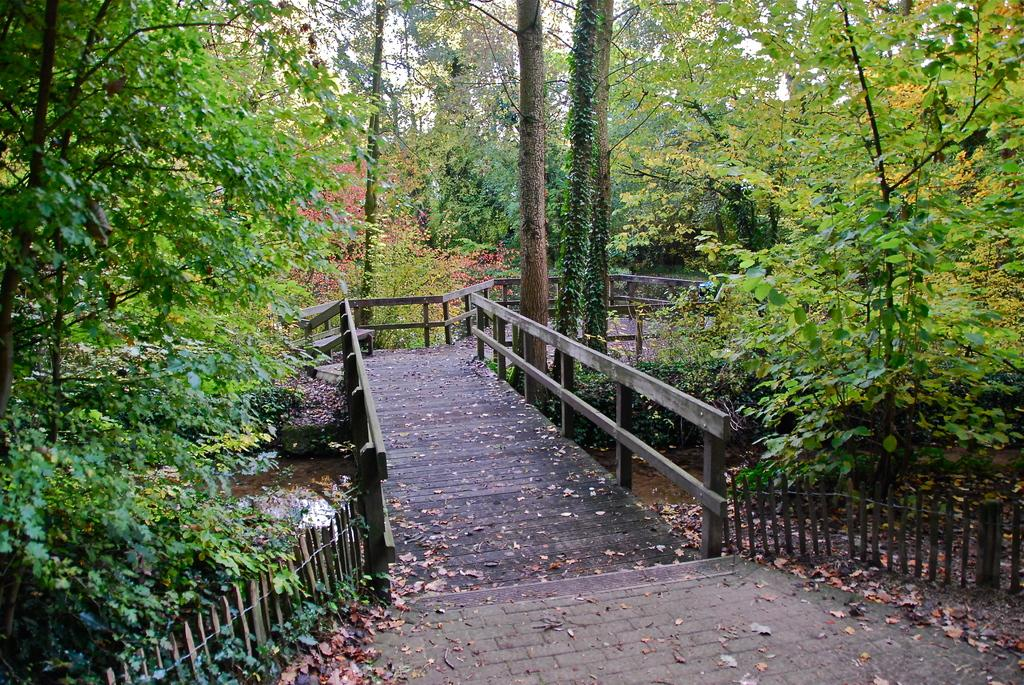What structure is the main subject of the image? There is a bridge in the image. What feature can be seen on the bridge? The bridge has fences. What type of vegetation is present near the bridge? There are trees on both sides of the bridge. What can be seen in the background of the image? There are trees in the background of the image. Where is the baby holding the parcel in the image? There is no baby or parcel present in the image; it only features a bridge with fences and trees. What territory is being claimed by the trees in the image? The trees in the image do not represent any territorial claims. 